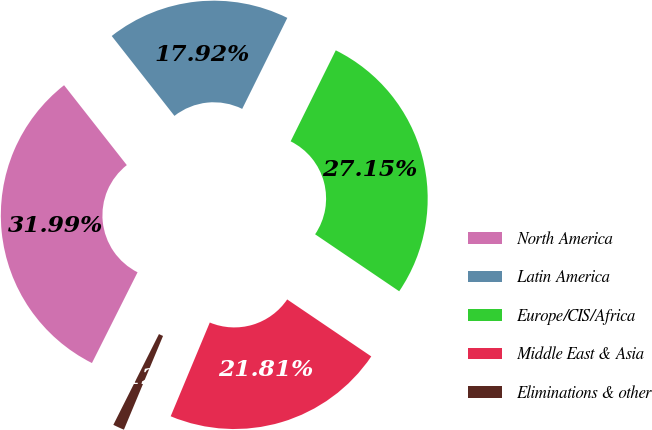Convert chart to OTSL. <chart><loc_0><loc_0><loc_500><loc_500><pie_chart><fcel>North America<fcel>Latin America<fcel>Europe/CIS/Africa<fcel>Middle East & Asia<fcel>Eliminations & other<nl><fcel>31.99%<fcel>17.92%<fcel>27.15%<fcel>21.81%<fcel>1.12%<nl></chart> 